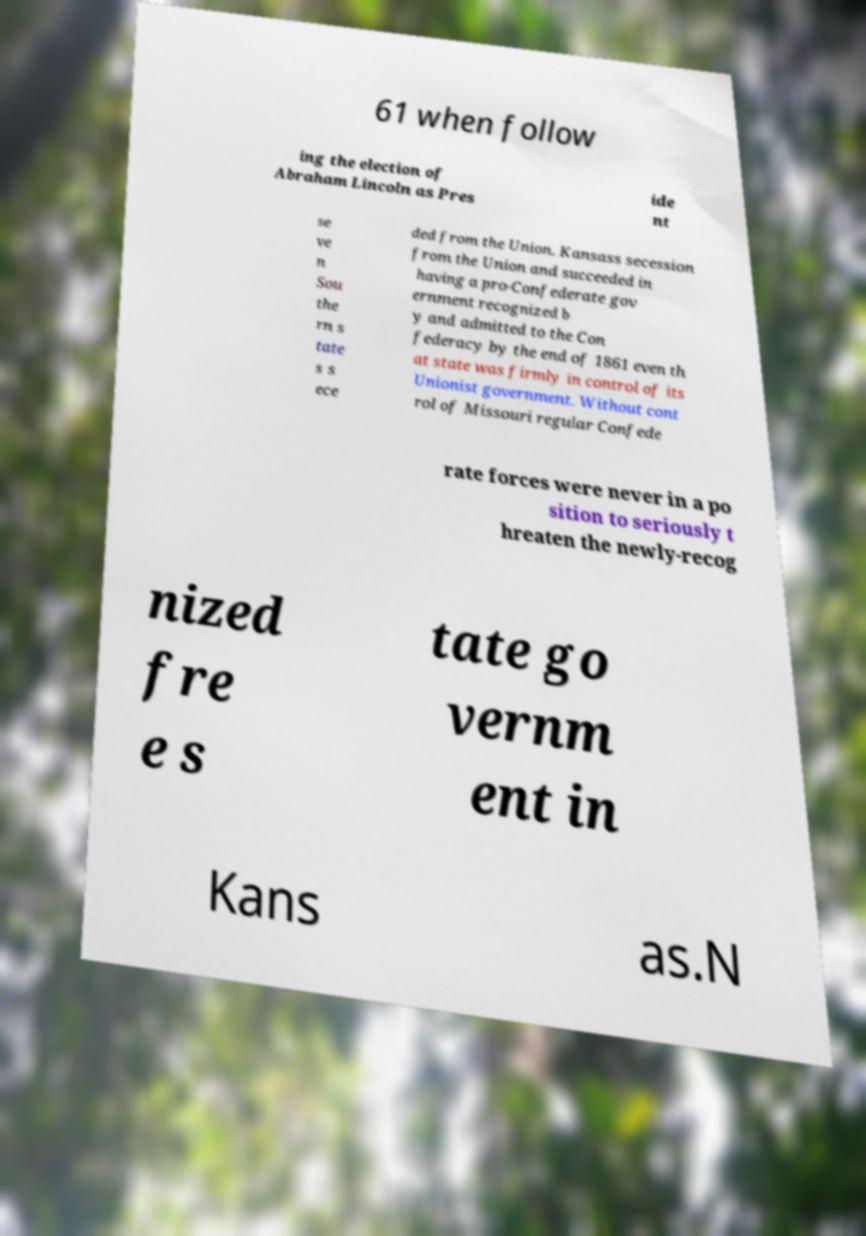Could you assist in decoding the text presented in this image and type it out clearly? 61 when follow ing the election of Abraham Lincoln as Pres ide nt se ve n Sou the rn s tate s s ece ded from the Union. Kansass secession from the Union and succeeded in having a pro-Confederate gov ernment recognized b y and admitted to the Con federacy by the end of 1861 even th at state was firmly in control of its Unionist government. Without cont rol of Missouri regular Confede rate forces were never in a po sition to seriously t hreaten the newly-recog nized fre e s tate go vernm ent in Kans as.N 